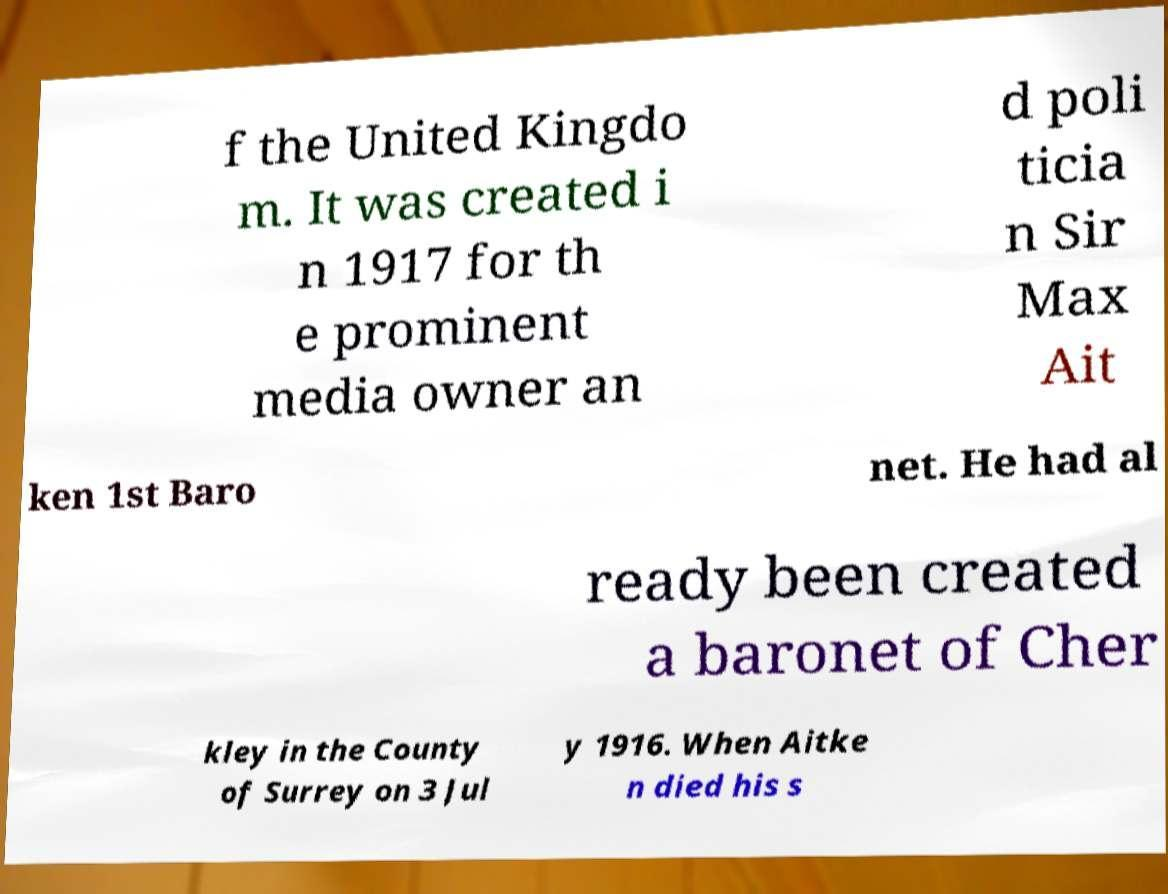Please identify and transcribe the text found in this image. f the United Kingdo m. It was created i n 1917 for th e prominent media owner an d poli ticia n Sir Max Ait ken 1st Baro net. He had al ready been created a baronet of Cher kley in the County of Surrey on 3 Jul y 1916. When Aitke n died his s 